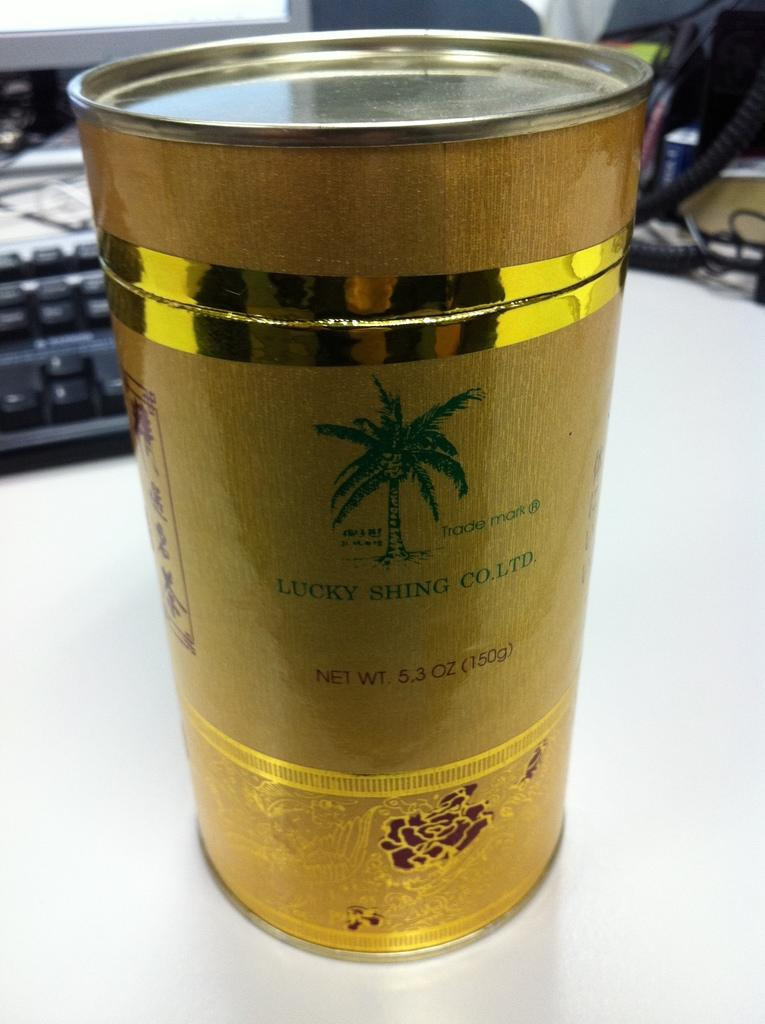<image>
Describe the image concisely. a golden can with a green palm tree and Lucky Shing Co. Ltd. sits on a table in front of a keyboard 